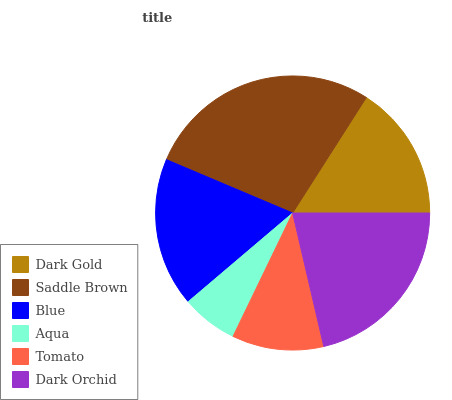Is Aqua the minimum?
Answer yes or no. Yes. Is Saddle Brown the maximum?
Answer yes or no. Yes. Is Blue the minimum?
Answer yes or no. No. Is Blue the maximum?
Answer yes or no. No. Is Saddle Brown greater than Blue?
Answer yes or no. Yes. Is Blue less than Saddle Brown?
Answer yes or no. Yes. Is Blue greater than Saddle Brown?
Answer yes or no. No. Is Saddle Brown less than Blue?
Answer yes or no. No. Is Blue the high median?
Answer yes or no. Yes. Is Dark Gold the low median?
Answer yes or no. Yes. Is Dark Gold the high median?
Answer yes or no. No. Is Aqua the low median?
Answer yes or no. No. 